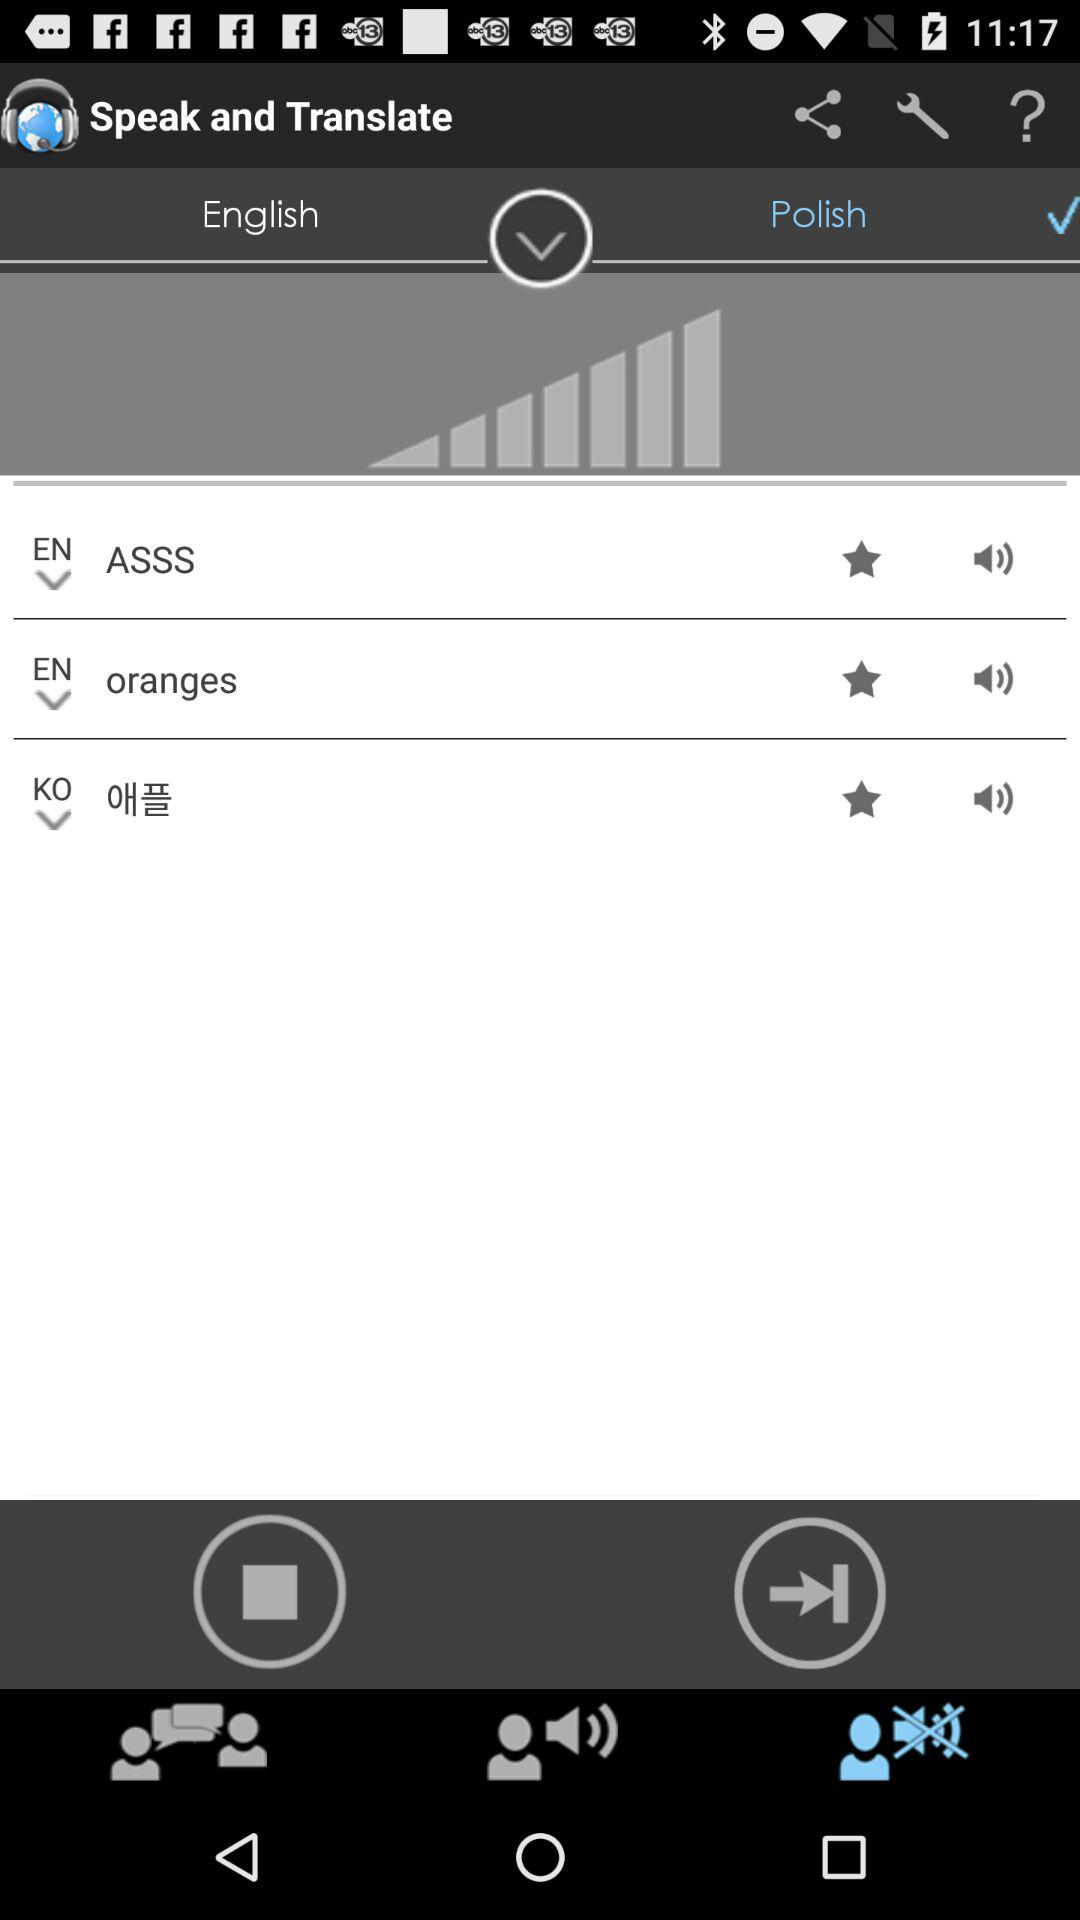What is the name of the application? The name of the application is "Speak and Translate". 